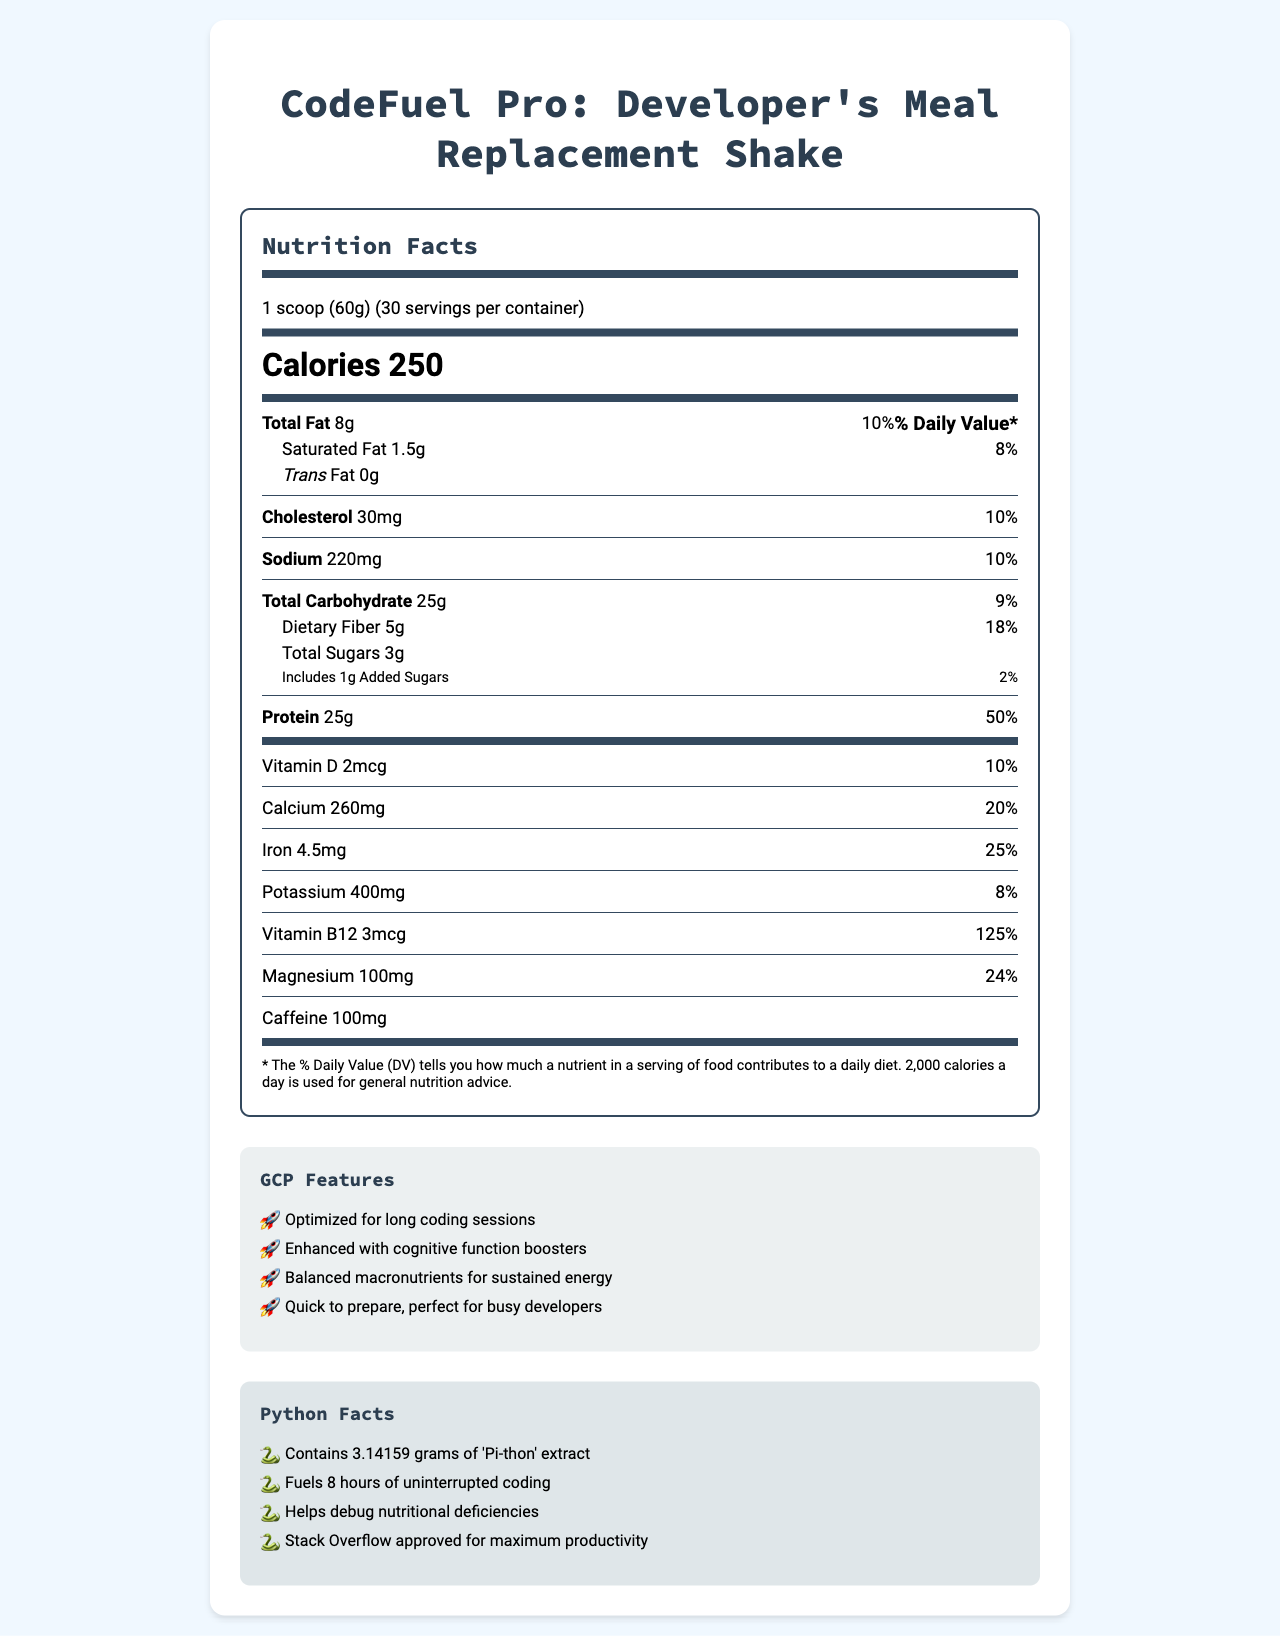what is the serving size of the meal replacement shake? The serving size is explicitly stated in the nutrition facts section as "1 scoop (60g)".
Answer: 1 scoop (60g) how many calories are in one serving of the shake? The calories are prominently displayed under the "Calories" section as "250".
Answer: 250 list three key protein sources in the shake The ingredients list includes "Whey protein isolate", "Pea protein", and "Brown rice protein" as the main protein sources.
Answer: Whey protein isolate, Pea protein, Brown rice protein what is the percentage daily value of vitamin B12? The nutrition facts section lists the daily value of vitamin B12 as 125%.
Answer: 125% how much dietary fiber does a serving contain? The nutritional information specifies that each serving contains 5g of dietary fiber.
Answer: 5g What is the source of caffeine in the shake? A. Coffee extract B. Green tea extract C. Guarana extract The ingredients list includes "Green tea extract," which is the source of caffeine listed in the document.
Answer: B. Green tea extract How many grams of total fat are in one serving? A. 5g B. 8g C. 10g D. 12g The nutrition facts indicate that there are 8 grams of total fat in one serving of the shake.
Answer: B. 8g Does this product contain any trans fat? The nutrition facts section shows "Trans Fat 0g," indicating it contains no trans fat.
Answer: No, it contains 0g trans fat can this shake be used by individuals with milk allergies? The allergens section states "Contains milk," implying it's not suitable for individuals with milk allergies.
Answer: No what are some of the cognitive function boosters included in the shake? These ingredients known for their cognitive function-boosting properties are listed in the ingredients section and nutrition facts.
Answer: L-theanine, Green tea extract, Vitamin B12 Describe the main features of the CodeFuel Pro shake. The document outlines these features in the "GCP Features" and "Python Facts" sections, indicating its suitability and benefits for developers.
Answer: The CodeFuel Pro shake is designed as a meal replacement for developers, optimized for long coding sessions. It has a balanced macronutrient profile to provide sustained energy, includes cognitive function boosters, and is quick to prepare. how much potassium is in one serving? The nutrition facts section lists potassium content as 400mg per serving.
Answer: 400mg how should the shake be prepared? The preparation instructions are listed at the end of the document.
Answer: Mix one scoop (60g) with 300ml of cold water or milk. Stir or shake until dissolved. Is the product Stack Overflow approved for maximum productivity? The "Python Facts" section explicitly states, "Stack Overflow approved for maximum productivity."
Answer: Yes what is the percentage daily value of calcium? The nutrition facts section shows that the daily value for calcium is 20%.
Answer: 20% how should the product be stored? The storage instructions are at the end of the document.
Answer: Store in a cool, dry place. Shake well before use. What's the meal replacement shake's daily value of iron? The nutrition facts section shows that iron has a daily value of 25%.
Answer: 25% Are the serving size and preparation method mentioned work friendly for long coding sessions? Whether the serving size and preparation method are work-friendly for long coding sessions is subjective and cannot be determined merely from the provided nutritional and preparation information.
Answer: Cannot be determined 